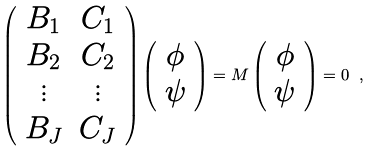<formula> <loc_0><loc_0><loc_500><loc_500>\left ( \begin{array} { c c } B _ { 1 } & C _ { 1 } \\ B _ { 2 } & C _ { 2 } \\ \vdots & \vdots \\ B _ { J } & C _ { J } \end{array} \right ) \left ( \begin{array} { c } \phi \\ \psi \end{array} \right ) = M \left ( \begin{array} { c } \phi \\ \psi \end{array} \right ) = 0 \ ,</formula> 